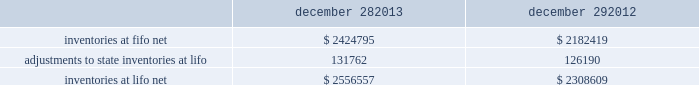Advance auto parts , inc .
And subsidiaries notes to the consolidated financial statements december 28 , 2013 , december 29 , 2012 and december 31 , 2011 ( in thousands , except per share data ) in july 2012 , the fasb issued asu no .
2012-02 201cintangible-goodwill and other 2013 testing indefinite-lived intangible assets for impairment . 201d asu 2012-02 modifies the requirement to test intangible assets that are not subject to amortization based on events or changes in circumstances that might indicate that the asset is impaired now requiring the test only if it is more likely than not that the asset is impaired .
Furthermore , asu 2012-02 provides entities the option of performing a qualitative assessment to determine if it is more likely than not that the fair value of an intangible asset is less than the carrying amount as a basis for determining whether it is necessary to perform a quantitative impairment test .
Asu 2012-02 is effective for fiscal years beginning after september 15 , 2012 and early adoption is permitted .
The adoption of asu 2012-02 had no impact on the company 2019s consolidated financial condition , results of operations or cash flows .
Inventories , net : merchandise inventory the company used the lifo method of accounting for approximately 95% ( 95 % ) of inventories at both december 28 , 2013 and december 29 , 2012 .
Under lifo , the company 2019s cost of sales reflects the costs of the most recently purchased inventories , while the inventory carrying balance represents the costs for inventories purchased in fiscal 2013 and prior years .
The company recorded a reduction to cost of sales of $ 5572 and $ 24087 in fiscal 2013 and fiscal 2012 , respectively .
The company 2019s overall costs to acquire inventory for the same or similar products have generally decreased historically as the company has been able to leverage its continued growth , execution of merchandise strategies and realization of supply chain efficiencies .
In fiscal 2011 , the company recorded an increase to cost of sales of $ 24708 due to an increase in supply chain costs and inflationary pressures affecting certain product categories .
Product cores the remaining inventories are comprised of product cores , the non-consumable portion of certain parts and batteries , which are valued under the first-in , first-out ( 201cfifo 201d ) method .
Product cores are included as part of the company 2019s merchandise costs and are either passed on to the customer or returned to the vendor .
Because product cores are not subject to frequent cost changes like the company 2019s other merchandise inventory , there is no material difference when applying either the lifo or fifo valuation method .
Inventory overhead costs purchasing and warehousing costs included in inventory as of december 28 , 2013 and december 29 , 2012 , were $ 161519 and $ 134258 , respectively .
Inventory balance and inventory reserves inventory balances at the end of fiscal 2013 and 2012 were as follows : december 28 , december 29 .
Inventory quantities are tracked through a perpetual inventory system .
The company completes physical inventories and other targeted inventory counts in its store locations to ensure the accuracy of the perpetual inventory quantities of both merchandise and core inventory in these locations .
In its distribution centers and pdq aes , the company uses a cycle counting program to ensure the accuracy of the perpetual inventory quantities of both merchandise and product core inventory .
Reserves for estimated shrink are established based on the results of physical inventories conducted by the company with the assistance of an independent third party in substantially all of the company 2019s stores over the course of the year , other targeted inventory counts in its stores , results from recent cycle counts in its distribution facilities and historical and current loss trends. .
What is the percentage increase in inventories balance due to the adoption of lifo in 2013? 
Computations: (131762 / 2424795)
Answer: 0.05434. 